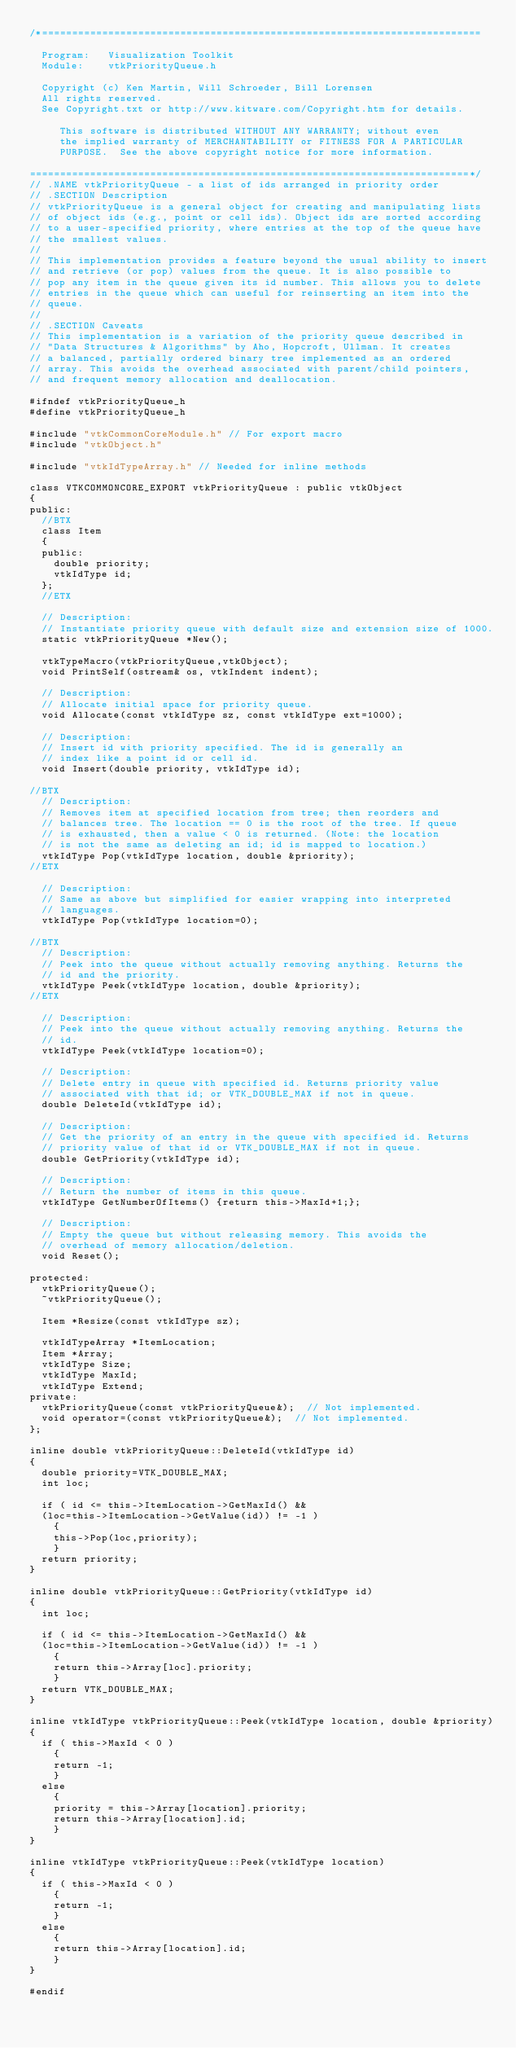<code> <loc_0><loc_0><loc_500><loc_500><_C_>/*=========================================================================

  Program:   Visualization Toolkit
  Module:    vtkPriorityQueue.h

  Copyright (c) Ken Martin, Will Schroeder, Bill Lorensen
  All rights reserved.
  See Copyright.txt or http://www.kitware.com/Copyright.htm for details.

     This software is distributed WITHOUT ANY WARRANTY; without even
     the implied warranty of MERCHANTABILITY or FITNESS FOR A PARTICULAR
     PURPOSE.  See the above copyright notice for more information.

=========================================================================*/
// .NAME vtkPriorityQueue - a list of ids arranged in priority order
// .SECTION Description
// vtkPriorityQueue is a general object for creating and manipulating lists
// of object ids (e.g., point or cell ids). Object ids are sorted according
// to a user-specified priority, where entries at the top of the queue have
// the smallest values.
//
// This implementation provides a feature beyond the usual ability to insert
// and retrieve (or pop) values from the queue. It is also possible to
// pop any item in the queue given its id number. This allows you to delete
// entries in the queue which can useful for reinserting an item into the
// queue.
//
// .SECTION Caveats
// This implementation is a variation of the priority queue described in
// "Data Structures & Algorithms" by Aho, Hopcroft, Ullman. It creates
// a balanced, partially ordered binary tree implemented as an ordered
// array. This avoids the overhead associated with parent/child pointers,
// and frequent memory allocation and deallocation.

#ifndef vtkPriorityQueue_h
#define vtkPriorityQueue_h

#include "vtkCommonCoreModule.h" // For export macro
#include "vtkObject.h"

#include "vtkIdTypeArray.h" // Needed for inline methods

class VTKCOMMONCORE_EXPORT vtkPriorityQueue : public vtkObject
{
public:
  //BTX
  class Item
  {
  public:
    double priority;
    vtkIdType id;
  };
  //ETX

  // Description:
  // Instantiate priority queue with default size and extension size of 1000.
  static vtkPriorityQueue *New();

  vtkTypeMacro(vtkPriorityQueue,vtkObject);
  void PrintSelf(ostream& os, vtkIndent indent);

  // Description:
  // Allocate initial space for priority queue.
  void Allocate(const vtkIdType sz, const vtkIdType ext=1000);

  // Description:
  // Insert id with priority specified. The id is generally an
  // index like a point id or cell id.
  void Insert(double priority, vtkIdType id);

//BTX
  // Description:
  // Removes item at specified location from tree; then reorders and
  // balances tree. The location == 0 is the root of the tree. If queue
  // is exhausted, then a value < 0 is returned. (Note: the location
  // is not the same as deleting an id; id is mapped to location.)
  vtkIdType Pop(vtkIdType location, double &priority);
//ETX

  // Description:
  // Same as above but simplified for easier wrapping into interpreted
  // languages.
  vtkIdType Pop(vtkIdType location=0);

//BTX
  // Description:
  // Peek into the queue without actually removing anything. Returns the
  // id and the priority.
  vtkIdType Peek(vtkIdType location, double &priority);
//ETX

  // Description:
  // Peek into the queue without actually removing anything. Returns the
  // id.
  vtkIdType Peek(vtkIdType location=0);

  // Description:
  // Delete entry in queue with specified id. Returns priority value
  // associated with that id; or VTK_DOUBLE_MAX if not in queue.
  double DeleteId(vtkIdType id);

  // Description:
  // Get the priority of an entry in the queue with specified id. Returns
  // priority value of that id or VTK_DOUBLE_MAX if not in queue.
  double GetPriority(vtkIdType id);

  // Description:
  // Return the number of items in this queue.
  vtkIdType GetNumberOfItems() {return this->MaxId+1;};

  // Description:
  // Empty the queue but without releasing memory. This avoids the
  // overhead of memory allocation/deletion.
  void Reset();

protected:
  vtkPriorityQueue();
  ~vtkPriorityQueue();

  Item *Resize(const vtkIdType sz);

  vtkIdTypeArray *ItemLocation;
  Item *Array;
  vtkIdType Size;
  vtkIdType MaxId;
  vtkIdType Extend;
private:
  vtkPriorityQueue(const vtkPriorityQueue&);  // Not implemented.
  void operator=(const vtkPriorityQueue&);  // Not implemented.
};

inline double vtkPriorityQueue::DeleteId(vtkIdType id)
{
  double priority=VTK_DOUBLE_MAX;
  int loc;

  if ( id <= this->ItemLocation->GetMaxId() &&
  (loc=this->ItemLocation->GetValue(id)) != -1 )
    {
    this->Pop(loc,priority);
    }
  return priority;
}

inline double vtkPriorityQueue::GetPriority(vtkIdType id)
{
  int loc;

  if ( id <= this->ItemLocation->GetMaxId() &&
  (loc=this->ItemLocation->GetValue(id)) != -1 )
    {
    return this->Array[loc].priority;
    }
  return VTK_DOUBLE_MAX;
}

inline vtkIdType vtkPriorityQueue::Peek(vtkIdType location, double &priority)
{
  if ( this->MaxId < 0 )
    {
    return -1;
    }
  else
    {
    priority = this->Array[location].priority;
    return this->Array[location].id;
    }
}

inline vtkIdType vtkPriorityQueue::Peek(vtkIdType location)
{
  if ( this->MaxId < 0 )
    {
    return -1;
    }
  else
    {
    return this->Array[location].id;
    }
}

#endif
</code> 